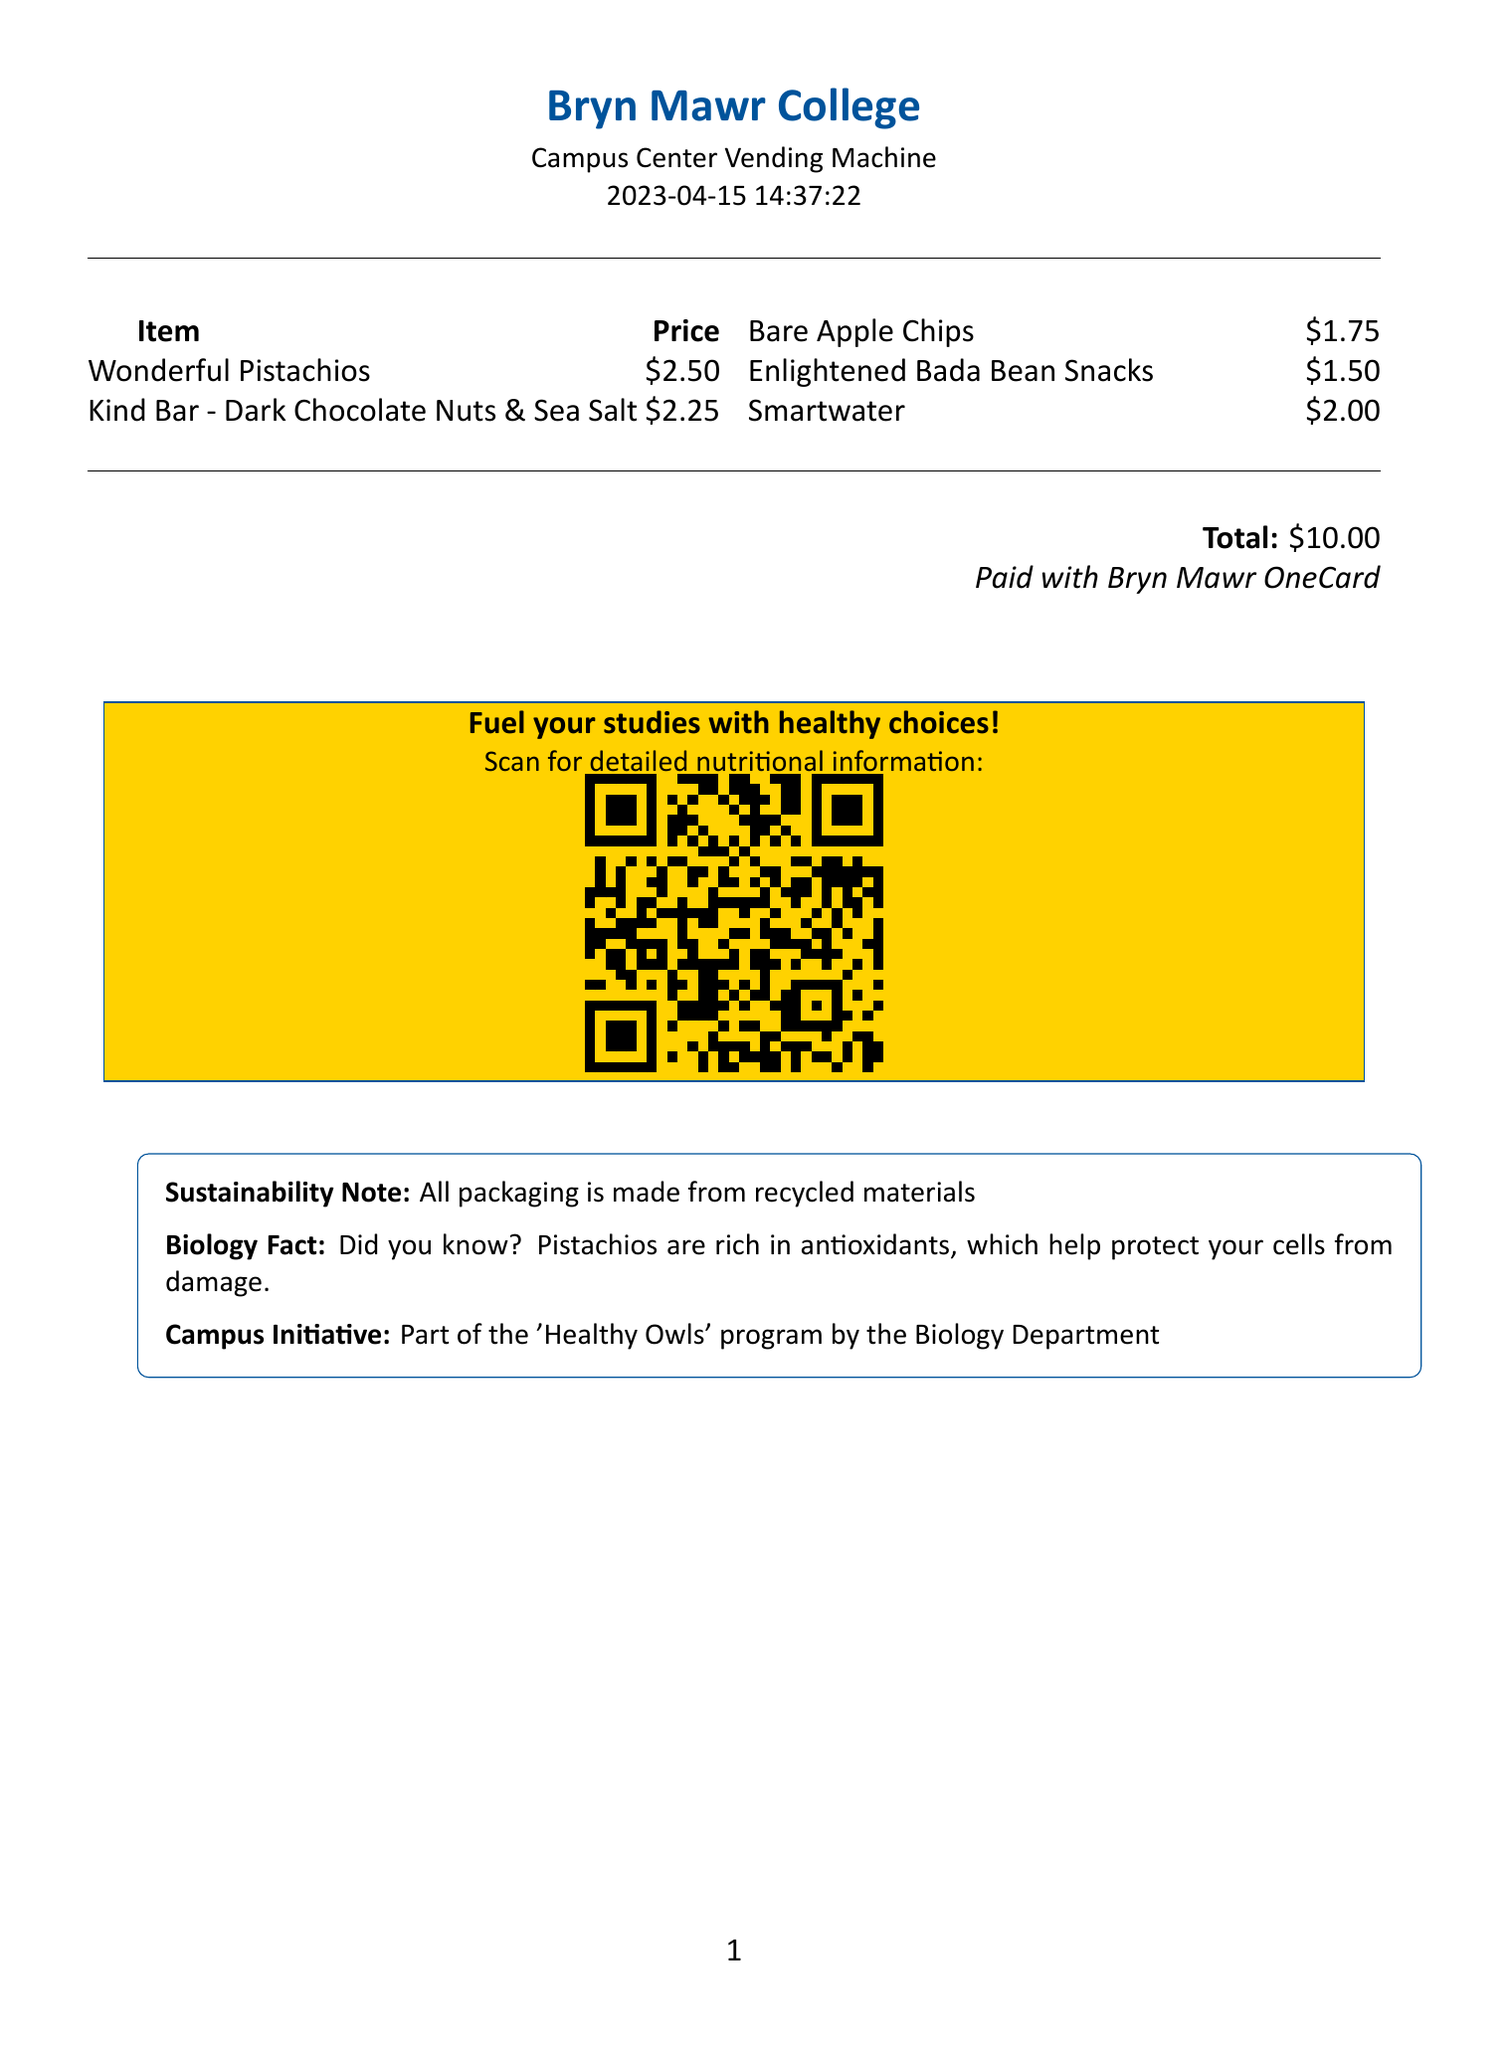What is the date of the receipt? The date is provided in the receipt header indicating when the transaction took place.
Answer: 2023-04-15 What item has the lowest price? By examining the prices of the items listed, the lowest price can be identified.
Answer: Enlightened Bada Bean Snacks How many calories are in the Kind Bar? The calorie count for the Kind Bar is specified in the item details.
Answer: 180 What was the total amount paid for the snacks? The total amount is calculated from the sum of all the item prices on the receipt.
Answer: 10.00 What payment method was used? The payment method is mentioned at the end of the receipt as part of the transaction information.
Answer: Bryn Mawr OneCard What message is displayed at the footer of the receipt? The footer contains a motivational message encouraging healthy choices.
Answer: Fuel your studies with healthy choices! How many calories are in Smartwater? The calorie information for Smartwater is necessary to answer this question based on the item description.
Answer: 0 What program is mentioned in the additional information? The text in the additional information section specifies a campus initiative related to health.
Answer: Healthy Owls What type of packaging is used for the snacks? There is a note in the additional information regarding the sustainability of the packaging used.
Answer: Recycled materials 